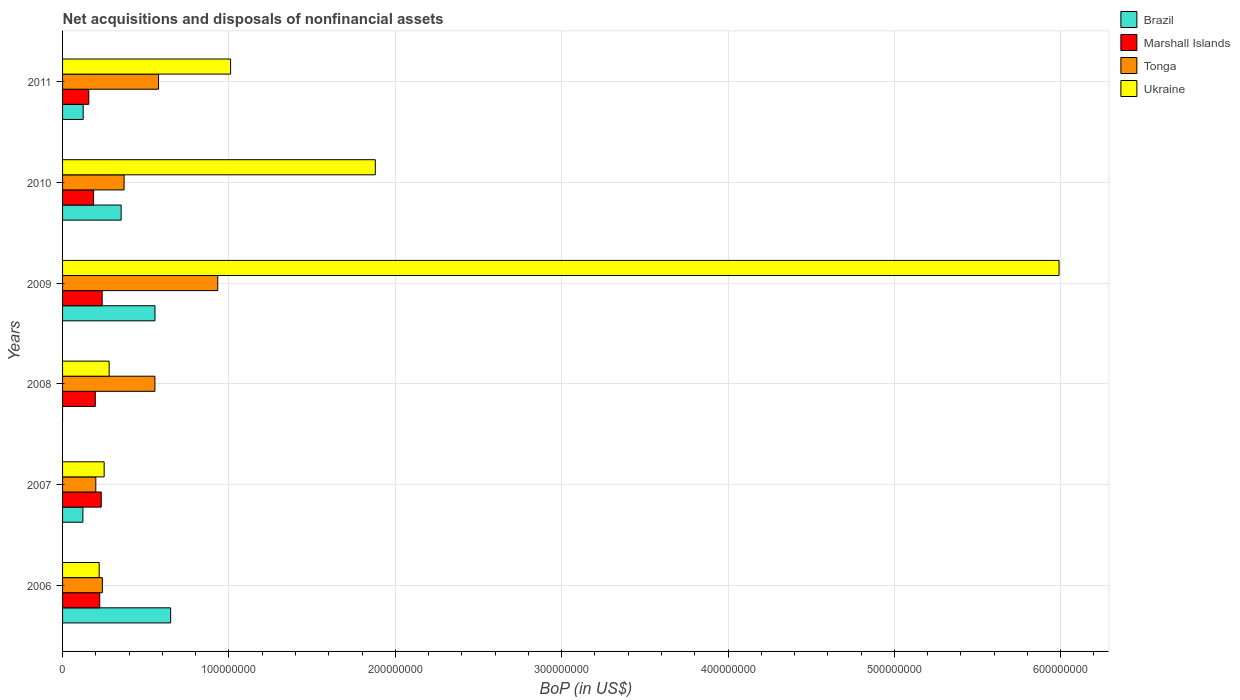How many bars are there on the 6th tick from the bottom?
Your response must be concise. 4. In how many cases, is the number of bars for a given year not equal to the number of legend labels?
Provide a short and direct response. 1. What is the Balance of Payments in Brazil in 2010?
Your answer should be very brief. 3.52e+07. Across all years, what is the maximum Balance of Payments in Brazil?
Your answer should be very brief. 6.50e+07. Across all years, what is the minimum Balance of Payments in Tonga?
Give a very brief answer. 2.00e+07. In which year was the Balance of Payments in Brazil maximum?
Offer a very short reply. 2006. What is the total Balance of Payments in Marshall Islands in the graph?
Ensure brevity in your answer.  1.23e+08. What is the difference between the Balance of Payments in Marshall Islands in 2007 and that in 2008?
Your answer should be very brief. 3.57e+06. What is the difference between the Balance of Payments in Ukraine in 2010 and the Balance of Payments in Brazil in 2009?
Keep it short and to the point. 1.32e+08. What is the average Balance of Payments in Brazil per year?
Provide a short and direct response. 3.01e+07. In the year 2009, what is the difference between the Balance of Payments in Tonga and Balance of Payments in Marshall Islands?
Offer a terse response. 6.95e+07. In how many years, is the Balance of Payments in Brazil greater than 60000000 US$?
Provide a short and direct response. 1. What is the ratio of the Balance of Payments in Ukraine in 2007 to that in 2008?
Provide a short and direct response. 0.89. What is the difference between the highest and the second highest Balance of Payments in Brazil?
Your answer should be very brief. 9.41e+06. What is the difference between the highest and the lowest Balance of Payments in Brazil?
Your answer should be very brief. 6.50e+07. In how many years, is the Balance of Payments in Tonga greater than the average Balance of Payments in Tonga taken over all years?
Your response must be concise. 3. Is it the case that in every year, the sum of the Balance of Payments in Ukraine and Balance of Payments in Brazil is greater than the Balance of Payments in Marshall Islands?
Keep it short and to the point. Yes. Are all the bars in the graph horizontal?
Offer a very short reply. Yes. How many years are there in the graph?
Give a very brief answer. 6. What is the difference between two consecutive major ticks on the X-axis?
Your response must be concise. 1.00e+08. Are the values on the major ticks of X-axis written in scientific E-notation?
Make the answer very short. No. Does the graph contain any zero values?
Offer a terse response. Yes. Does the graph contain grids?
Offer a very short reply. Yes. How many legend labels are there?
Offer a terse response. 4. What is the title of the graph?
Keep it short and to the point. Net acquisitions and disposals of nonfinancial assets. Does "Bolivia" appear as one of the legend labels in the graph?
Offer a very short reply. No. What is the label or title of the X-axis?
Keep it short and to the point. BoP (in US$). What is the BoP (in US$) of Brazil in 2006?
Offer a very short reply. 6.50e+07. What is the BoP (in US$) of Marshall Islands in 2006?
Offer a very short reply. 2.23e+07. What is the BoP (in US$) of Tonga in 2006?
Your response must be concise. 2.39e+07. What is the BoP (in US$) of Ukraine in 2006?
Keep it short and to the point. 2.20e+07. What is the BoP (in US$) of Brazil in 2007?
Offer a terse response. 1.22e+07. What is the BoP (in US$) of Marshall Islands in 2007?
Give a very brief answer. 2.32e+07. What is the BoP (in US$) of Tonga in 2007?
Give a very brief answer. 2.00e+07. What is the BoP (in US$) of Ukraine in 2007?
Make the answer very short. 2.50e+07. What is the BoP (in US$) in Brazil in 2008?
Keep it short and to the point. 0. What is the BoP (in US$) of Marshall Islands in 2008?
Make the answer very short. 1.97e+07. What is the BoP (in US$) in Tonga in 2008?
Your answer should be very brief. 5.55e+07. What is the BoP (in US$) in Ukraine in 2008?
Give a very brief answer. 2.80e+07. What is the BoP (in US$) in Brazil in 2009?
Your answer should be very brief. 5.56e+07. What is the BoP (in US$) in Marshall Islands in 2009?
Provide a short and direct response. 2.38e+07. What is the BoP (in US$) in Tonga in 2009?
Ensure brevity in your answer.  9.33e+07. What is the BoP (in US$) of Ukraine in 2009?
Make the answer very short. 5.99e+08. What is the BoP (in US$) of Brazil in 2010?
Provide a succinct answer. 3.52e+07. What is the BoP (in US$) of Marshall Islands in 2010?
Offer a very short reply. 1.86e+07. What is the BoP (in US$) in Tonga in 2010?
Offer a terse response. 3.70e+07. What is the BoP (in US$) of Ukraine in 2010?
Offer a very short reply. 1.88e+08. What is the BoP (in US$) in Brazil in 2011?
Make the answer very short. 1.24e+07. What is the BoP (in US$) in Marshall Islands in 2011?
Keep it short and to the point. 1.58e+07. What is the BoP (in US$) of Tonga in 2011?
Offer a very short reply. 5.77e+07. What is the BoP (in US$) of Ukraine in 2011?
Provide a short and direct response. 1.01e+08. Across all years, what is the maximum BoP (in US$) in Brazil?
Provide a short and direct response. 6.50e+07. Across all years, what is the maximum BoP (in US$) of Marshall Islands?
Make the answer very short. 2.38e+07. Across all years, what is the maximum BoP (in US$) of Tonga?
Give a very brief answer. 9.33e+07. Across all years, what is the maximum BoP (in US$) in Ukraine?
Offer a terse response. 5.99e+08. Across all years, what is the minimum BoP (in US$) in Brazil?
Keep it short and to the point. 0. Across all years, what is the minimum BoP (in US$) in Marshall Islands?
Provide a short and direct response. 1.58e+07. Across all years, what is the minimum BoP (in US$) in Tonga?
Offer a terse response. 2.00e+07. Across all years, what is the minimum BoP (in US$) in Ukraine?
Your answer should be compact. 2.20e+07. What is the total BoP (in US$) in Brazil in the graph?
Keep it short and to the point. 1.80e+08. What is the total BoP (in US$) of Marshall Islands in the graph?
Offer a terse response. 1.23e+08. What is the total BoP (in US$) in Tonga in the graph?
Your answer should be compact. 2.87e+08. What is the total BoP (in US$) of Ukraine in the graph?
Provide a short and direct response. 9.63e+08. What is the difference between the BoP (in US$) in Brazil in 2006 and that in 2007?
Your answer should be compact. 5.27e+07. What is the difference between the BoP (in US$) in Marshall Islands in 2006 and that in 2007?
Ensure brevity in your answer.  -9.06e+05. What is the difference between the BoP (in US$) in Tonga in 2006 and that in 2007?
Your answer should be very brief. 3.94e+06. What is the difference between the BoP (in US$) of Marshall Islands in 2006 and that in 2008?
Make the answer very short. 2.67e+06. What is the difference between the BoP (in US$) of Tonga in 2006 and that in 2008?
Provide a short and direct response. -3.16e+07. What is the difference between the BoP (in US$) in Ukraine in 2006 and that in 2008?
Your answer should be very brief. -6.00e+06. What is the difference between the BoP (in US$) in Brazil in 2006 and that in 2009?
Ensure brevity in your answer.  9.41e+06. What is the difference between the BoP (in US$) of Marshall Islands in 2006 and that in 2009?
Your response must be concise. -1.47e+06. What is the difference between the BoP (in US$) in Tonga in 2006 and that in 2009?
Make the answer very short. -6.94e+07. What is the difference between the BoP (in US$) of Ukraine in 2006 and that in 2009?
Give a very brief answer. -5.77e+08. What is the difference between the BoP (in US$) of Brazil in 2006 and that in 2010?
Offer a terse response. 2.98e+07. What is the difference between the BoP (in US$) in Marshall Islands in 2006 and that in 2010?
Provide a succinct answer. 3.70e+06. What is the difference between the BoP (in US$) in Tonga in 2006 and that in 2010?
Give a very brief answer. -1.31e+07. What is the difference between the BoP (in US$) of Ukraine in 2006 and that in 2010?
Provide a succinct answer. -1.66e+08. What is the difference between the BoP (in US$) of Brazil in 2006 and that in 2011?
Provide a succinct answer. 5.26e+07. What is the difference between the BoP (in US$) of Marshall Islands in 2006 and that in 2011?
Keep it short and to the point. 6.58e+06. What is the difference between the BoP (in US$) of Tonga in 2006 and that in 2011?
Provide a short and direct response. -3.38e+07. What is the difference between the BoP (in US$) of Ukraine in 2006 and that in 2011?
Give a very brief answer. -7.90e+07. What is the difference between the BoP (in US$) in Marshall Islands in 2007 and that in 2008?
Your answer should be compact. 3.57e+06. What is the difference between the BoP (in US$) of Tonga in 2007 and that in 2008?
Your response must be concise. -3.55e+07. What is the difference between the BoP (in US$) of Brazil in 2007 and that in 2009?
Keep it short and to the point. -4.33e+07. What is the difference between the BoP (in US$) in Marshall Islands in 2007 and that in 2009?
Offer a very short reply. -5.65e+05. What is the difference between the BoP (in US$) in Tonga in 2007 and that in 2009?
Ensure brevity in your answer.  -7.33e+07. What is the difference between the BoP (in US$) of Ukraine in 2007 and that in 2009?
Your response must be concise. -5.74e+08. What is the difference between the BoP (in US$) of Brazil in 2007 and that in 2010?
Your response must be concise. -2.30e+07. What is the difference between the BoP (in US$) in Marshall Islands in 2007 and that in 2010?
Offer a terse response. 4.61e+06. What is the difference between the BoP (in US$) of Tonga in 2007 and that in 2010?
Provide a short and direct response. -1.70e+07. What is the difference between the BoP (in US$) of Ukraine in 2007 and that in 2010?
Your response must be concise. -1.63e+08. What is the difference between the BoP (in US$) of Brazil in 2007 and that in 2011?
Your answer should be very brief. -1.81e+05. What is the difference between the BoP (in US$) of Marshall Islands in 2007 and that in 2011?
Ensure brevity in your answer.  7.48e+06. What is the difference between the BoP (in US$) of Tonga in 2007 and that in 2011?
Provide a short and direct response. -3.77e+07. What is the difference between the BoP (in US$) in Ukraine in 2007 and that in 2011?
Your answer should be compact. -7.60e+07. What is the difference between the BoP (in US$) in Marshall Islands in 2008 and that in 2009?
Your response must be concise. -4.14e+06. What is the difference between the BoP (in US$) in Tonga in 2008 and that in 2009?
Provide a succinct answer. -3.78e+07. What is the difference between the BoP (in US$) of Ukraine in 2008 and that in 2009?
Offer a very short reply. -5.71e+08. What is the difference between the BoP (in US$) of Marshall Islands in 2008 and that in 2010?
Give a very brief answer. 1.04e+06. What is the difference between the BoP (in US$) of Tonga in 2008 and that in 2010?
Provide a short and direct response. 1.85e+07. What is the difference between the BoP (in US$) of Ukraine in 2008 and that in 2010?
Your answer should be very brief. -1.60e+08. What is the difference between the BoP (in US$) of Marshall Islands in 2008 and that in 2011?
Keep it short and to the point. 3.91e+06. What is the difference between the BoP (in US$) of Tonga in 2008 and that in 2011?
Make the answer very short. -2.19e+06. What is the difference between the BoP (in US$) of Ukraine in 2008 and that in 2011?
Ensure brevity in your answer.  -7.30e+07. What is the difference between the BoP (in US$) of Brazil in 2009 and that in 2010?
Offer a very short reply. 2.03e+07. What is the difference between the BoP (in US$) in Marshall Islands in 2009 and that in 2010?
Provide a short and direct response. 5.17e+06. What is the difference between the BoP (in US$) of Tonga in 2009 and that in 2010?
Keep it short and to the point. 5.63e+07. What is the difference between the BoP (in US$) in Ukraine in 2009 and that in 2010?
Your answer should be compact. 4.11e+08. What is the difference between the BoP (in US$) of Brazil in 2009 and that in 2011?
Give a very brief answer. 4.31e+07. What is the difference between the BoP (in US$) of Marshall Islands in 2009 and that in 2011?
Give a very brief answer. 8.05e+06. What is the difference between the BoP (in US$) in Tonga in 2009 and that in 2011?
Your answer should be compact. 3.56e+07. What is the difference between the BoP (in US$) in Ukraine in 2009 and that in 2011?
Offer a terse response. 4.98e+08. What is the difference between the BoP (in US$) of Brazil in 2010 and that in 2011?
Ensure brevity in your answer.  2.28e+07. What is the difference between the BoP (in US$) of Marshall Islands in 2010 and that in 2011?
Your answer should be compact. 2.88e+06. What is the difference between the BoP (in US$) in Tonga in 2010 and that in 2011?
Your answer should be compact. -2.07e+07. What is the difference between the BoP (in US$) in Ukraine in 2010 and that in 2011?
Provide a succinct answer. 8.70e+07. What is the difference between the BoP (in US$) of Brazil in 2006 and the BoP (in US$) of Marshall Islands in 2007?
Your answer should be very brief. 4.17e+07. What is the difference between the BoP (in US$) of Brazil in 2006 and the BoP (in US$) of Tonga in 2007?
Offer a very short reply. 4.50e+07. What is the difference between the BoP (in US$) in Brazil in 2006 and the BoP (in US$) in Ukraine in 2007?
Offer a very short reply. 4.00e+07. What is the difference between the BoP (in US$) in Marshall Islands in 2006 and the BoP (in US$) in Tonga in 2007?
Give a very brief answer. 2.36e+06. What is the difference between the BoP (in US$) of Marshall Islands in 2006 and the BoP (in US$) of Ukraine in 2007?
Your response must be concise. -2.66e+06. What is the difference between the BoP (in US$) of Tonga in 2006 and the BoP (in US$) of Ukraine in 2007?
Keep it short and to the point. -1.08e+06. What is the difference between the BoP (in US$) of Brazil in 2006 and the BoP (in US$) of Marshall Islands in 2008?
Ensure brevity in your answer.  4.53e+07. What is the difference between the BoP (in US$) of Brazil in 2006 and the BoP (in US$) of Tonga in 2008?
Give a very brief answer. 9.46e+06. What is the difference between the BoP (in US$) in Brazil in 2006 and the BoP (in US$) in Ukraine in 2008?
Ensure brevity in your answer.  3.70e+07. What is the difference between the BoP (in US$) in Marshall Islands in 2006 and the BoP (in US$) in Tonga in 2008?
Ensure brevity in your answer.  -3.32e+07. What is the difference between the BoP (in US$) in Marshall Islands in 2006 and the BoP (in US$) in Ukraine in 2008?
Your answer should be compact. -5.66e+06. What is the difference between the BoP (in US$) in Tonga in 2006 and the BoP (in US$) in Ukraine in 2008?
Offer a terse response. -4.08e+06. What is the difference between the BoP (in US$) of Brazil in 2006 and the BoP (in US$) of Marshall Islands in 2009?
Offer a terse response. 4.12e+07. What is the difference between the BoP (in US$) in Brazil in 2006 and the BoP (in US$) in Tonga in 2009?
Keep it short and to the point. -2.83e+07. What is the difference between the BoP (in US$) in Brazil in 2006 and the BoP (in US$) in Ukraine in 2009?
Your answer should be compact. -5.34e+08. What is the difference between the BoP (in US$) of Marshall Islands in 2006 and the BoP (in US$) of Tonga in 2009?
Your answer should be compact. -7.09e+07. What is the difference between the BoP (in US$) in Marshall Islands in 2006 and the BoP (in US$) in Ukraine in 2009?
Give a very brief answer. -5.77e+08. What is the difference between the BoP (in US$) of Tonga in 2006 and the BoP (in US$) of Ukraine in 2009?
Your answer should be compact. -5.75e+08. What is the difference between the BoP (in US$) of Brazil in 2006 and the BoP (in US$) of Marshall Islands in 2010?
Give a very brief answer. 4.63e+07. What is the difference between the BoP (in US$) in Brazil in 2006 and the BoP (in US$) in Tonga in 2010?
Provide a short and direct response. 2.80e+07. What is the difference between the BoP (in US$) of Brazil in 2006 and the BoP (in US$) of Ukraine in 2010?
Give a very brief answer. -1.23e+08. What is the difference between the BoP (in US$) of Marshall Islands in 2006 and the BoP (in US$) of Tonga in 2010?
Offer a very short reply. -1.46e+07. What is the difference between the BoP (in US$) in Marshall Islands in 2006 and the BoP (in US$) in Ukraine in 2010?
Your answer should be compact. -1.66e+08. What is the difference between the BoP (in US$) in Tonga in 2006 and the BoP (in US$) in Ukraine in 2010?
Offer a very short reply. -1.64e+08. What is the difference between the BoP (in US$) of Brazil in 2006 and the BoP (in US$) of Marshall Islands in 2011?
Provide a succinct answer. 4.92e+07. What is the difference between the BoP (in US$) of Brazil in 2006 and the BoP (in US$) of Tonga in 2011?
Your answer should be very brief. 7.27e+06. What is the difference between the BoP (in US$) of Brazil in 2006 and the BoP (in US$) of Ukraine in 2011?
Make the answer very short. -3.60e+07. What is the difference between the BoP (in US$) of Marshall Islands in 2006 and the BoP (in US$) of Tonga in 2011?
Provide a short and direct response. -3.54e+07. What is the difference between the BoP (in US$) in Marshall Islands in 2006 and the BoP (in US$) in Ukraine in 2011?
Provide a short and direct response. -7.87e+07. What is the difference between the BoP (in US$) of Tonga in 2006 and the BoP (in US$) of Ukraine in 2011?
Keep it short and to the point. -7.71e+07. What is the difference between the BoP (in US$) of Brazil in 2007 and the BoP (in US$) of Marshall Islands in 2008?
Provide a succinct answer. -7.44e+06. What is the difference between the BoP (in US$) of Brazil in 2007 and the BoP (in US$) of Tonga in 2008?
Provide a succinct answer. -4.33e+07. What is the difference between the BoP (in US$) of Brazil in 2007 and the BoP (in US$) of Ukraine in 2008?
Keep it short and to the point. -1.58e+07. What is the difference between the BoP (in US$) of Marshall Islands in 2007 and the BoP (in US$) of Tonga in 2008?
Your answer should be very brief. -3.23e+07. What is the difference between the BoP (in US$) in Marshall Islands in 2007 and the BoP (in US$) in Ukraine in 2008?
Your answer should be compact. -4.76e+06. What is the difference between the BoP (in US$) in Tonga in 2007 and the BoP (in US$) in Ukraine in 2008?
Offer a terse response. -8.02e+06. What is the difference between the BoP (in US$) of Brazil in 2007 and the BoP (in US$) of Marshall Islands in 2009?
Make the answer very short. -1.16e+07. What is the difference between the BoP (in US$) of Brazil in 2007 and the BoP (in US$) of Tonga in 2009?
Ensure brevity in your answer.  -8.11e+07. What is the difference between the BoP (in US$) in Brazil in 2007 and the BoP (in US$) in Ukraine in 2009?
Offer a terse response. -5.87e+08. What is the difference between the BoP (in US$) in Marshall Islands in 2007 and the BoP (in US$) in Tonga in 2009?
Your response must be concise. -7.00e+07. What is the difference between the BoP (in US$) of Marshall Islands in 2007 and the BoP (in US$) of Ukraine in 2009?
Your answer should be compact. -5.76e+08. What is the difference between the BoP (in US$) of Tonga in 2007 and the BoP (in US$) of Ukraine in 2009?
Offer a terse response. -5.79e+08. What is the difference between the BoP (in US$) of Brazil in 2007 and the BoP (in US$) of Marshall Islands in 2010?
Your answer should be compact. -6.41e+06. What is the difference between the BoP (in US$) of Brazil in 2007 and the BoP (in US$) of Tonga in 2010?
Your answer should be very brief. -2.48e+07. What is the difference between the BoP (in US$) in Brazil in 2007 and the BoP (in US$) in Ukraine in 2010?
Offer a very short reply. -1.76e+08. What is the difference between the BoP (in US$) of Marshall Islands in 2007 and the BoP (in US$) of Tonga in 2010?
Ensure brevity in your answer.  -1.37e+07. What is the difference between the BoP (in US$) in Marshall Islands in 2007 and the BoP (in US$) in Ukraine in 2010?
Your answer should be compact. -1.65e+08. What is the difference between the BoP (in US$) of Tonga in 2007 and the BoP (in US$) of Ukraine in 2010?
Give a very brief answer. -1.68e+08. What is the difference between the BoP (in US$) in Brazil in 2007 and the BoP (in US$) in Marshall Islands in 2011?
Make the answer very short. -3.53e+06. What is the difference between the BoP (in US$) in Brazil in 2007 and the BoP (in US$) in Tonga in 2011?
Your response must be concise. -4.55e+07. What is the difference between the BoP (in US$) in Brazil in 2007 and the BoP (in US$) in Ukraine in 2011?
Provide a succinct answer. -8.88e+07. What is the difference between the BoP (in US$) in Marshall Islands in 2007 and the BoP (in US$) in Tonga in 2011?
Make the answer very short. -3.45e+07. What is the difference between the BoP (in US$) of Marshall Islands in 2007 and the BoP (in US$) of Ukraine in 2011?
Offer a very short reply. -7.78e+07. What is the difference between the BoP (in US$) in Tonga in 2007 and the BoP (in US$) in Ukraine in 2011?
Provide a short and direct response. -8.10e+07. What is the difference between the BoP (in US$) in Marshall Islands in 2008 and the BoP (in US$) in Tonga in 2009?
Keep it short and to the point. -7.36e+07. What is the difference between the BoP (in US$) of Marshall Islands in 2008 and the BoP (in US$) of Ukraine in 2009?
Provide a succinct answer. -5.79e+08. What is the difference between the BoP (in US$) of Tonga in 2008 and the BoP (in US$) of Ukraine in 2009?
Provide a succinct answer. -5.43e+08. What is the difference between the BoP (in US$) of Marshall Islands in 2008 and the BoP (in US$) of Tonga in 2010?
Offer a terse response. -1.73e+07. What is the difference between the BoP (in US$) of Marshall Islands in 2008 and the BoP (in US$) of Ukraine in 2010?
Your response must be concise. -1.68e+08. What is the difference between the BoP (in US$) of Tonga in 2008 and the BoP (in US$) of Ukraine in 2010?
Provide a short and direct response. -1.32e+08. What is the difference between the BoP (in US$) of Marshall Islands in 2008 and the BoP (in US$) of Tonga in 2011?
Provide a succinct answer. -3.80e+07. What is the difference between the BoP (in US$) in Marshall Islands in 2008 and the BoP (in US$) in Ukraine in 2011?
Make the answer very short. -8.13e+07. What is the difference between the BoP (in US$) of Tonga in 2008 and the BoP (in US$) of Ukraine in 2011?
Keep it short and to the point. -4.55e+07. What is the difference between the BoP (in US$) of Brazil in 2009 and the BoP (in US$) of Marshall Islands in 2010?
Give a very brief answer. 3.69e+07. What is the difference between the BoP (in US$) of Brazil in 2009 and the BoP (in US$) of Tonga in 2010?
Make the answer very short. 1.86e+07. What is the difference between the BoP (in US$) of Brazil in 2009 and the BoP (in US$) of Ukraine in 2010?
Offer a very short reply. -1.32e+08. What is the difference between the BoP (in US$) in Marshall Islands in 2009 and the BoP (in US$) in Tonga in 2010?
Offer a terse response. -1.32e+07. What is the difference between the BoP (in US$) in Marshall Islands in 2009 and the BoP (in US$) in Ukraine in 2010?
Make the answer very short. -1.64e+08. What is the difference between the BoP (in US$) in Tonga in 2009 and the BoP (in US$) in Ukraine in 2010?
Offer a very short reply. -9.47e+07. What is the difference between the BoP (in US$) of Brazil in 2009 and the BoP (in US$) of Marshall Islands in 2011?
Ensure brevity in your answer.  3.98e+07. What is the difference between the BoP (in US$) of Brazil in 2009 and the BoP (in US$) of Tonga in 2011?
Offer a very short reply. -2.14e+06. What is the difference between the BoP (in US$) of Brazil in 2009 and the BoP (in US$) of Ukraine in 2011?
Provide a short and direct response. -4.54e+07. What is the difference between the BoP (in US$) in Marshall Islands in 2009 and the BoP (in US$) in Tonga in 2011?
Your answer should be very brief. -3.39e+07. What is the difference between the BoP (in US$) of Marshall Islands in 2009 and the BoP (in US$) of Ukraine in 2011?
Provide a succinct answer. -7.72e+07. What is the difference between the BoP (in US$) of Tonga in 2009 and the BoP (in US$) of Ukraine in 2011?
Keep it short and to the point. -7.72e+06. What is the difference between the BoP (in US$) in Brazil in 2010 and the BoP (in US$) in Marshall Islands in 2011?
Your answer should be compact. 1.95e+07. What is the difference between the BoP (in US$) in Brazil in 2010 and the BoP (in US$) in Tonga in 2011?
Your response must be concise. -2.25e+07. What is the difference between the BoP (in US$) in Brazil in 2010 and the BoP (in US$) in Ukraine in 2011?
Keep it short and to the point. -6.58e+07. What is the difference between the BoP (in US$) in Marshall Islands in 2010 and the BoP (in US$) in Tonga in 2011?
Ensure brevity in your answer.  -3.91e+07. What is the difference between the BoP (in US$) in Marshall Islands in 2010 and the BoP (in US$) in Ukraine in 2011?
Keep it short and to the point. -8.24e+07. What is the difference between the BoP (in US$) of Tonga in 2010 and the BoP (in US$) of Ukraine in 2011?
Your answer should be very brief. -6.40e+07. What is the average BoP (in US$) in Brazil per year?
Provide a succinct answer. 3.01e+07. What is the average BoP (in US$) in Marshall Islands per year?
Provide a short and direct response. 2.06e+07. What is the average BoP (in US$) of Tonga per year?
Keep it short and to the point. 4.79e+07. What is the average BoP (in US$) of Ukraine per year?
Offer a very short reply. 1.60e+08. In the year 2006, what is the difference between the BoP (in US$) of Brazil and BoP (in US$) of Marshall Islands?
Provide a short and direct response. 4.26e+07. In the year 2006, what is the difference between the BoP (in US$) of Brazil and BoP (in US$) of Tonga?
Give a very brief answer. 4.10e+07. In the year 2006, what is the difference between the BoP (in US$) of Brazil and BoP (in US$) of Ukraine?
Offer a terse response. 4.30e+07. In the year 2006, what is the difference between the BoP (in US$) in Marshall Islands and BoP (in US$) in Tonga?
Offer a very short reply. -1.58e+06. In the year 2006, what is the difference between the BoP (in US$) of Marshall Islands and BoP (in US$) of Ukraine?
Make the answer very short. 3.38e+05. In the year 2006, what is the difference between the BoP (in US$) in Tonga and BoP (in US$) in Ukraine?
Offer a terse response. 1.92e+06. In the year 2007, what is the difference between the BoP (in US$) of Brazil and BoP (in US$) of Marshall Islands?
Offer a terse response. -1.10e+07. In the year 2007, what is the difference between the BoP (in US$) in Brazil and BoP (in US$) in Tonga?
Provide a succinct answer. -7.75e+06. In the year 2007, what is the difference between the BoP (in US$) of Brazil and BoP (in US$) of Ukraine?
Your answer should be very brief. -1.28e+07. In the year 2007, what is the difference between the BoP (in US$) in Marshall Islands and BoP (in US$) in Tonga?
Your answer should be compact. 3.27e+06. In the year 2007, what is the difference between the BoP (in US$) in Marshall Islands and BoP (in US$) in Ukraine?
Your response must be concise. -1.76e+06. In the year 2007, what is the difference between the BoP (in US$) of Tonga and BoP (in US$) of Ukraine?
Make the answer very short. -5.02e+06. In the year 2008, what is the difference between the BoP (in US$) of Marshall Islands and BoP (in US$) of Tonga?
Keep it short and to the point. -3.58e+07. In the year 2008, what is the difference between the BoP (in US$) in Marshall Islands and BoP (in US$) in Ukraine?
Provide a succinct answer. -8.33e+06. In the year 2008, what is the difference between the BoP (in US$) in Tonga and BoP (in US$) in Ukraine?
Keep it short and to the point. 2.75e+07. In the year 2009, what is the difference between the BoP (in US$) in Brazil and BoP (in US$) in Marshall Islands?
Provide a short and direct response. 3.17e+07. In the year 2009, what is the difference between the BoP (in US$) in Brazil and BoP (in US$) in Tonga?
Your response must be concise. -3.77e+07. In the year 2009, what is the difference between the BoP (in US$) of Brazil and BoP (in US$) of Ukraine?
Your response must be concise. -5.43e+08. In the year 2009, what is the difference between the BoP (in US$) of Marshall Islands and BoP (in US$) of Tonga?
Give a very brief answer. -6.95e+07. In the year 2009, what is the difference between the BoP (in US$) in Marshall Islands and BoP (in US$) in Ukraine?
Your answer should be compact. -5.75e+08. In the year 2009, what is the difference between the BoP (in US$) in Tonga and BoP (in US$) in Ukraine?
Give a very brief answer. -5.06e+08. In the year 2010, what is the difference between the BoP (in US$) of Brazil and BoP (in US$) of Marshall Islands?
Make the answer very short. 1.66e+07. In the year 2010, what is the difference between the BoP (in US$) in Brazil and BoP (in US$) in Tonga?
Give a very brief answer. -1.78e+06. In the year 2010, what is the difference between the BoP (in US$) of Brazil and BoP (in US$) of Ukraine?
Provide a succinct answer. -1.53e+08. In the year 2010, what is the difference between the BoP (in US$) in Marshall Islands and BoP (in US$) in Tonga?
Give a very brief answer. -1.83e+07. In the year 2010, what is the difference between the BoP (in US$) of Marshall Islands and BoP (in US$) of Ukraine?
Provide a succinct answer. -1.69e+08. In the year 2010, what is the difference between the BoP (in US$) in Tonga and BoP (in US$) in Ukraine?
Give a very brief answer. -1.51e+08. In the year 2011, what is the difference between the BoP (in US$) of Brazil and BoP (in US$) of Marshall Islands?
Provide a succinct answer. -3.35e+06. In the year 2011, what is the difference between the BoP (in US$) of Brazil and BoP (in US$) of Tonga?
Your answer should be compact. -4.53e+07. In the year 2011, what is the difference between the BoP (in US$) of Brazil and BoP (in US$) of Ukraine?
Offer a very short reply. -8.86e+07. In the year 2011, what is the difference between the BoP (in US$) in Marshall Islands and BoP (in US$) in Tonga?
Make the answer very short. -4.19e+07. In the year 2011, what is the difference between the BoP (in US$) of Marshall Islands and BoP (in US$) of Ukraine?
Keep it short and to the point. -8.52e+07. In the year 2011, what is the difference between the BoP (in US$) of Tonga and BoP (in US$) of Ukraine?
Your answer should be compact. -4.33e+07. What is the ratio of the BoP (in US$) of Brazil in 2006 to that in 2007?
Provide a short and direct response. 5.31. What is the ratio of the BoP (in US$) of Marshall Islands in 2006 to that in 2007?
Offer a terse response. 0.96. What is the ratio of the BoP (in US$) of Tonga in 2006 to that in 2007?
Make the answer very short. 1.2. What is the ratio of the BoP (in US$) in Marshall Islands in 2006 to that in 2008?
Provide a succinct answer. 1.14. What is the ratio of the BoP (in US$) of Tonga in 2006 to that in 2008?
Your answer should be compact. 0.43. What is the ratio of the BoP (in US$) in Ukraine in 2006 to that in 2008?
Your answer should be very brief. 0.79. What is the ratio of the BoP (in US$) of Brazil in 2006 to that in 2009?
Provide a short and direct response. 1.17. What is the ratio of the BoP (in US$) of Marshall Islands in 2006 to that in 2009?
Offer a very short reply. 0.94. What is the ratio of the BoP (in US$) in Tonga in 2006 to that in 2009?
Offer a very short reply. 0.26. What is the ratio of the BoP (in US$) in Ukraine in 2006 to that in 2009?
Offer a very short reply. 0.04. What is the ratio of the BoP (in US$) of Brazil in 2006 to that in 2010?
Keep it short and to the point. 1.84. What is the ratio of the BoP (in US$) of Marshall Islands in 2006 to that in 2010?
Make the answer very short. 1.2. What is the ratio of the BoP (in US$) of Tonga in 2006 to that in 2010?
Your answer should be compact. 0.65. What is the ratio of the BoP (in US$) in Ukraine in 2006 to that in 2010?
Make the answer very short. 0.12. What is the ratio of the BoP (in US$) in Brazil in 2006 to that in 2011?
Offer a terse response. 5.24. What is the ratio of the BoP (in US$) of Marshall Islands in 2006 to that in 2011?
Provide a succinct answer. 1.42. What is the ratio of the BoP (in US$) in Tonga in 2006 to that in 2011?
Offer a very short reply. 0.41. What is the ratio of the BoP (in US$) of Ukraine in 2006 to that in 2011?
Give a very brief answer. 0.22. What is the ratio of the BoP (in US$) in Marshall Islands in 2007 to that in 2008?
Keep it short and to the point. 1.18. What is the ratio of the BoP (in US$) of Tonga in 2007 to that in 2008?
Your response must be concise. 0.36. What is the ratio of the BoP (in US$) in Ukraine in 2007 to that in 2008?
Keep it short and to the point. 0.89. What is the ratio of the BoP (in US$) in Brazil in 2007 to that in 2009?
Offer a very short reply. 0.22. What is the ratio of the BoP (in US$) in Marshall Islands in 2007 to that in 2009?
Keep it short and to the point. 0.98. What is the ratio of the BoP (in US$) in Tonga in 2007 to that in 2009?
Provide a short and direct response. 0.21. What is the ratio of the BoP (in US$) in Ukraine in 2007 to that in 2009?
Your answer should be very brief. 0.04. What is the ratio of the BoP (in US$) of Brazil in 2007 to that in 2010?
Offer a very short reply. 0.35. What is the ratio of the BoP (in US$) of Marshall Islands in 2007 to that in 2010?
Your response must be concise. 1.25. What is the ratio of the BoP (in US$) in Tonga in 2007 to that in 2010?
Ensure brevity in your answer.  0.54. What is the ratio of the BoP (in US$) of Ukraine in 2007 to that in 2010?
Provide a short and direct response. 0.13. What is the ratio of the BoP (in US$) of Brazil in 2007 to that in 2011?
Offer a very short reply. 0.99. What is the ratio of the BoP (in US$) of Marshall Islands in 2007 to that in 2011?
Your response must be concise. 1.47. What is the ratio of the BoP (in US$) in Tonga in 2007 to that in 2011?
Give a very brief answer. 0.35. What is the ratio of the BoP (in US$) of Ukraine in 2007 to that in 2011?
Provide a succinct answer. 0.25. What is the ratio of the BoP (in US$) of Marshall Islands in 2008 to that in 2009?
Your answer should be very brief. 0.83. What is the ratio of the BoP (in US$) in Tonga in 2008 to that in 2009?
Give a very brief answer. 0.6. What is the ratio of the BoP (in US$) of Ukraine in 2008 to that in 2009?
Ensure brevity in your answer.  0.05. What is the ratio of the BoP (in US$) in Marshall Islands in 2008 to that in 2010?
Your answer should be very brief. 1.06. What is the ratio of the BoP (in US$) in Tonga in 2008 to that in 2010?
Make the answer very short. 1.5. What is the ratio of the BoP (in US$) in Ukraine in 2008 to that in 2010?
Keep it short and to the point. 0.15. What is the ratio of the BoP (in US$) in Marshall Islands in 2008 to that in 2011?
Provide a short and direct response. 1.25. What is the ratio of the BoP (in US$) in Tonga in 2008 to that in 2011?
Offer a terse response. 0.96. What is the ratio of the BoP (in US$) of Ukraine in 2008 to that in 2011?
Ensure brevity in your answer.  0.28. What is the ratio of the BoP (in US$) of Brazil in 2009 to that in 2010?
Provide a succinct answer. 1.58. What is the ratio of the BoP (in US$) in Marshall Islands in 2009 to that in 2010?
Offer a terse response. 1.28. What is the ratio of the BoP (in US$) of Tonga in 2009 to that in 2010?
Your answer should be very brief. 2.52. What is the ratio of the BoP (in US$) of Ukraine in 2009 to that in 2010?
Provide a succinct answer. 3.19. What is the ratio of the BoP (in US$) in Brazil in 2009 to that in 2011?
Keep it short and to the point. 4.48. What is the ratio of the BoP (in US$) of Marshall Islands in 2009 to that in 2011?
Provide a succinct answer. 1.51. What is the ratio of the BoP (in US$) of Tonga in 2009 to that in 2011?
Make the answer very short. 1.62. What is the ratio of the BoP (in US$) of Ukraine in 2009 to that in 2011?
Your answer should be very brief. 5.93. What is the ratio of the BoP (in US$) of Brazil in 2010 to that in 2011?
Your answer should be very brief. 2.84. What is the ratio of the BoP (in US$) of Marshall Islands in 2010 to that in 2011?
Offer a terse response. 1.18. What is the ratio of the BoP (in US$) in Tonga in 2010 to that in 2011?
Give a very brief answer. 0.64. What is the ratio of the BoP (in US$) in Ukraine in 2010 to that in 2011?
Give a very brief answer. 1.86. What is the difference between the highest and the second highest BoP (in US$) of Brazil?
Provide a short and direct response. 9.41e+06. What is the difference between the highest and the second highest BoP (in US$) in Marshall Islands?
Your answer should be very brief. 5.65e+05. What is the difference between the highest and the second highest BoP (in US$) of Tonga?
Provide a succinct answer. 3.56e+07. What is the difference between the highest and the second highest BoP (in US$) in Ukraine?
Ensure brevity in your answer.  4.11e+08. What is the difference between the highest and the lowest BoP (in US$) of Brazil?
Offer a very short reply. 6.50e+07. What is the difference between the highest and the lowest BoP (in US$) in Marshall Islands?
Give a very brief answer. 8.05e+06. What is the difference between the highest and the lowest BoP (in US$) of Tonga?
Provide a succinct answer. 7.33e+07. What is the difference between the highest and the lowest BoP (in US$) in Ukraine?
Ensure brevity in your answer.  5.77e+08. 